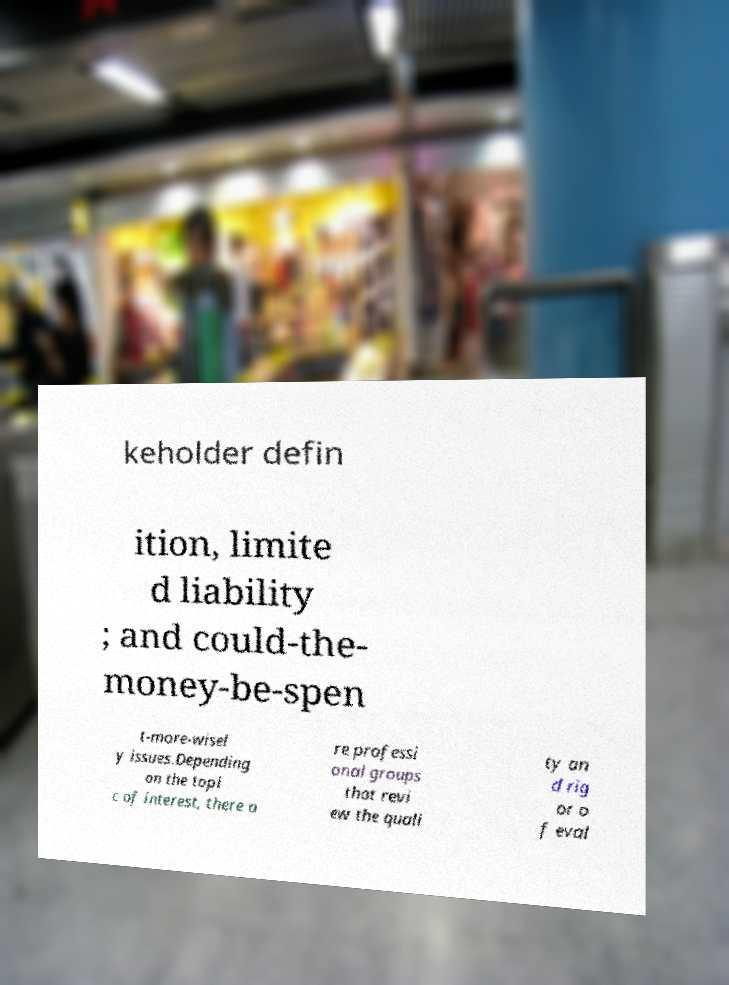Could you extract and type out the text from this image? keholder defin ition, limite d liability ; and could-the- money-be-spen t-more-wisel y issues.Depending on the topi c of interest, there a re professi onal groups that revi ew the quali ty an d rig or o f eval 